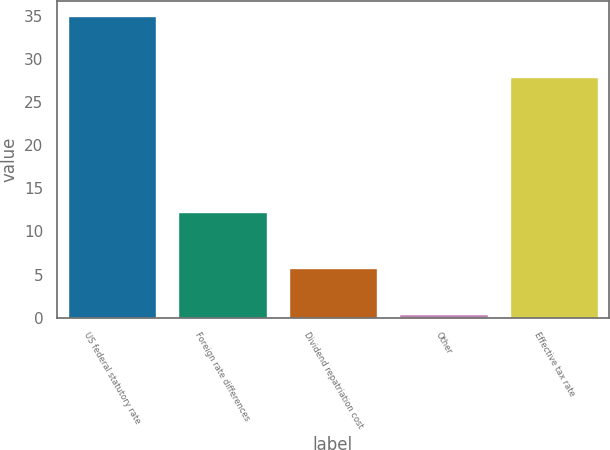Convert chart. <chart><loc_0><loc_0><loc_500><loc_500><bar_chart><fcel>US federal statutory rate<fcel>Foreign rate differences<fcel>Dividend repatriation cost<fcel>Other<fcel>Effective tax rate<nl><fcel>35<fcel>12.3<fcel>5.7<fcel>0.4<fcel>28<nl></chart> 